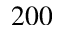<formula> <loc_0><loc_0><loc_500><loc_500>2 0 0</formula> 